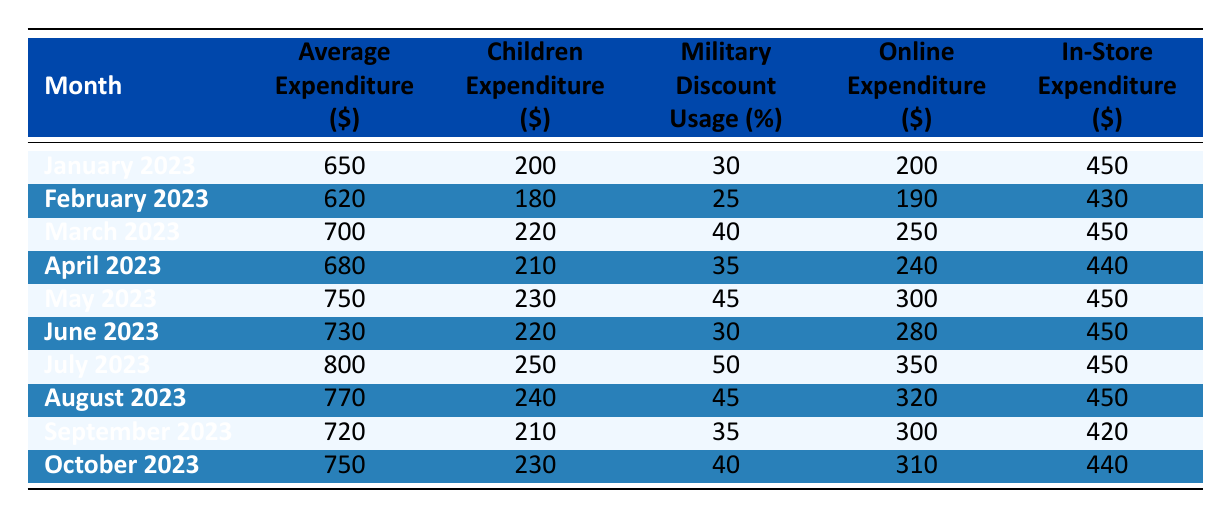What was the average expenditure in July 2023? The table lists July 2023 with an average expenditure of 800.
Answer: 800 What was the percentage of military discount usage in March 2023? The table shows that the military discount usage in March 2023 was 40%.
Answer: 40% Which month had the lowest average expenditure? Scanning the table, February 2023 shows the lowest average expenditure at 620.
Answer: February 2023 What is the difference between average expenditures in May and January 2023? The average expenditure in May 2023 was 750, and in January 2023 it was 650. The difference is 750 - 650 = 100.
Answer: 100 Did the average expenditure increase from June to July 2023? In June 2023, the average expenditure was 730, and in July 2023 it increased to 800. So, yes, it increased.
Answer: Yes Which month had an average expenditure greater than 700 and also used the military discount more than 40%? Reviewing the table, both May (750, 45%) and July (800, 50%) meet these criteria. So there are two months that satisfy the condition.
Answer: May and July How much did military families spend on children's expenditures in total from January to October 2023? The children's expenditure across the months totaled: 200 + 180 + 220 + 210 + 230 + 220 + 250 + 240 + 210 + 230 = 2260.
Answer: 2260 Which month had the highest online expenditure? The table indicates that July 2023 had the highest online expenditure at 350.
Answer: July 2023 Is there a month where the children’s expenditure was greater than the military discount usage percentage? In March 2023, the children’s expenditure (220) was greater than the military discount usage (40). So, yes, there are months like March.
Answer: Yes 